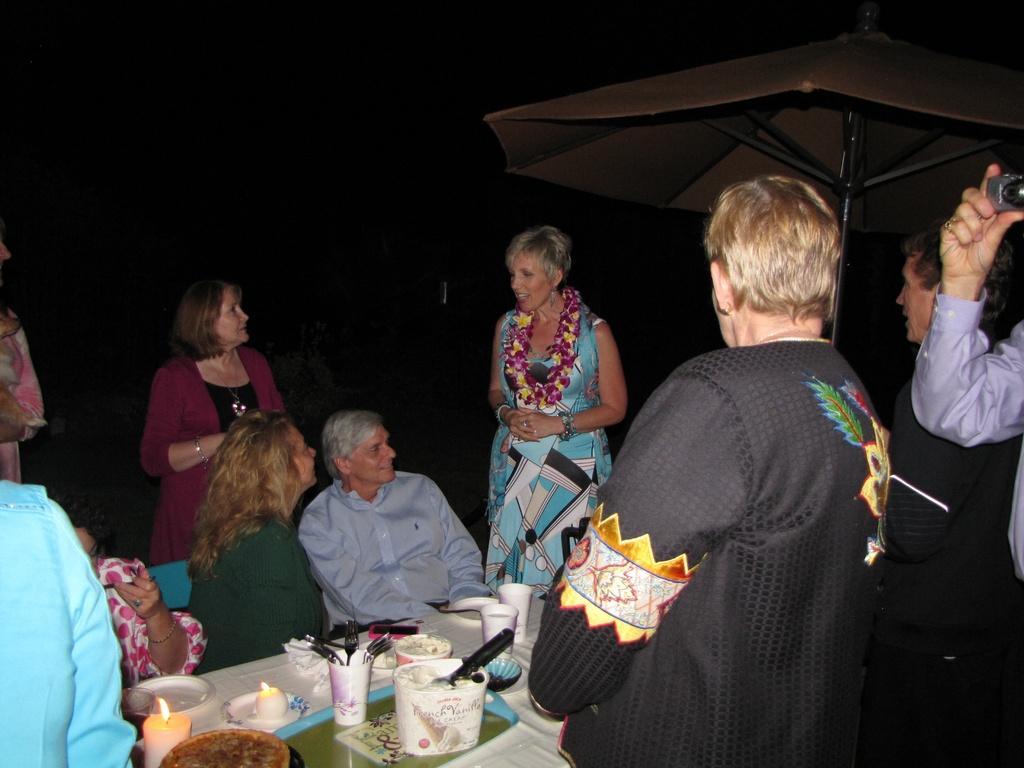Describe this image in one or two sentences. In this picture we can see group of people and few are sitting, in front of them we can see candles, cups and other things on the table, beside them we can see an umbrella, on the right side of the image we can see a person and the person is holding a camera. 